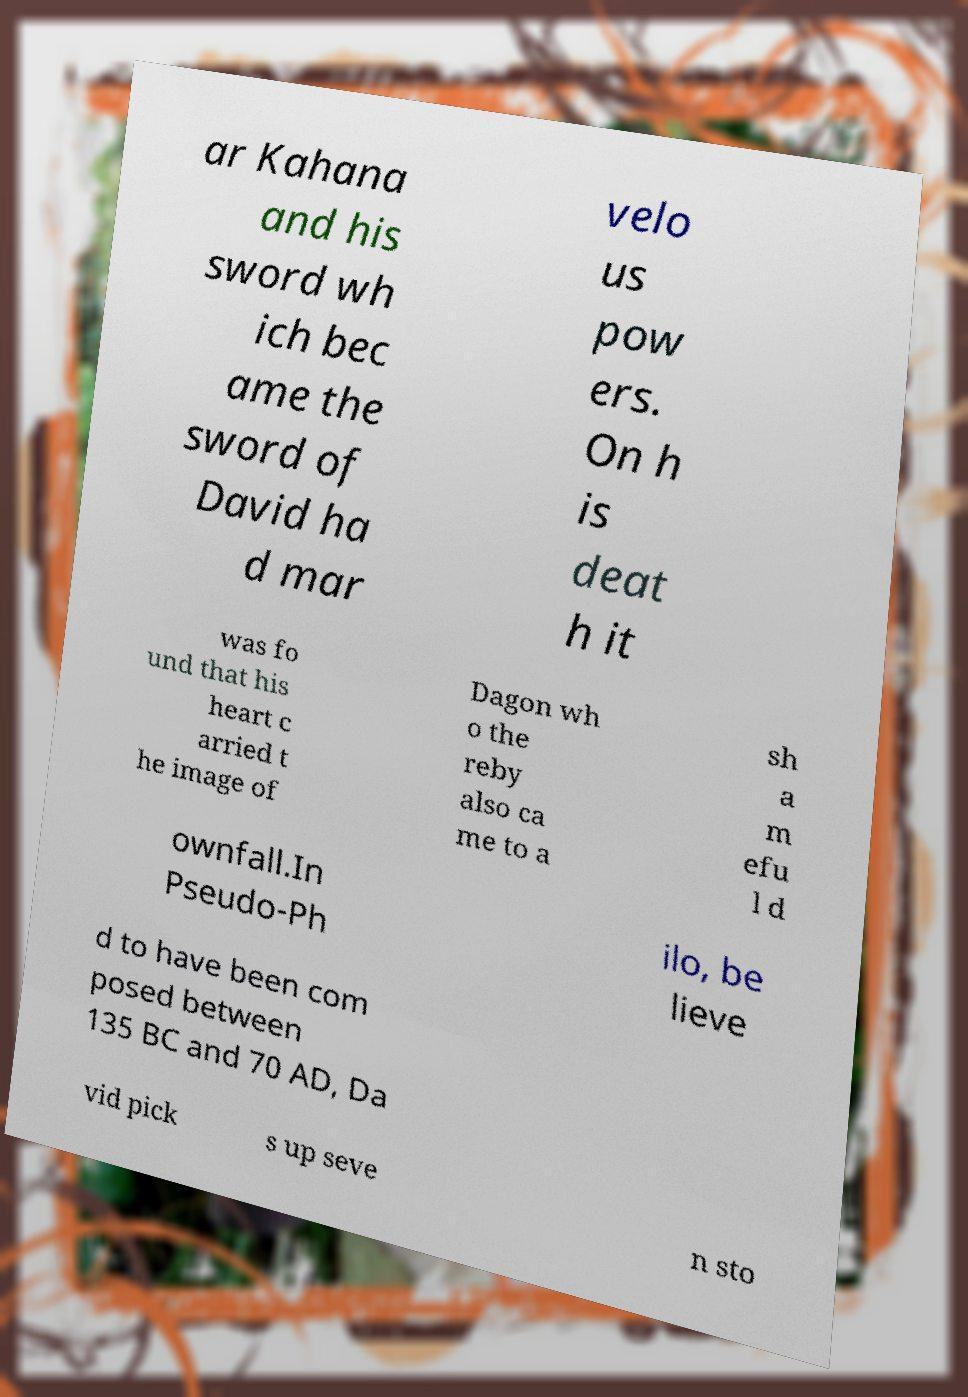Please identify and transcribe the text found in this image. ar Kahana and his sword wh ich bec ame the sword of David ha d mar velo us pow ers. On h is deat h it was fo und that his heart c arried t he image of Dagon wh o the reby also ca me to a sh a m efu l d ownfall.In Pseudo-Ph ilo, be lieve d to have been com posed between 135 BC and 70 AD, Da vid pick s up seve n sto 